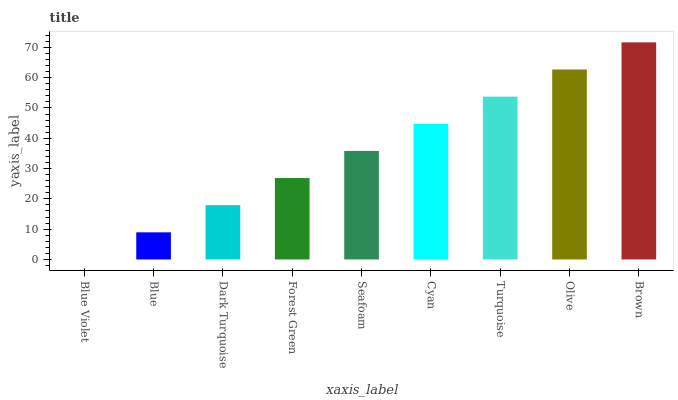Is Blue Violet the minimum?
Answer yes or no. Yes. Is Brown the maximum?
Answer yes or no. Yes. Is Blue the minimum?
Answer yes or no. No. Is Blue the maximum?
Answer yes or no. No. Is Blue greater than Blue Violet?
Answer yes or no. Yes. Is Blue Violet less than Blue?
Answer yes or no. Yes. Is Blue Violet greater than Blue?
Answer yes or no. No. Is Blue less than Blue Violet?
Answer yes or no. No. Is Seafoam the high median?
Answer yes or no. Yes. Is Seafoam the low median?
Answer yes or no. Yes. Is Brown the high median?
Answer yes or no. No. Is Olive the low median?
Answer yes or no. No. 